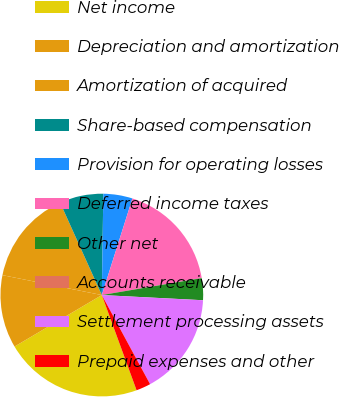<chart> <loc_0><loc_0><loc_500><loc_500><pie_chart><fcel>Net income<fcel>Depreciation and amortization<fcel>Amortization of acquired<fcel>Share-based compensation<fcel>Provision for operating losses<fcel>Deferred income taxes<fcel>Other net<fcel>Accounts receivable<fcel>Settlement processing assets<fcel>Prepaid expenses and other<nl><fcel>22.09%<fcel>11.63%<fcel>15.11%<fcel>6.98%<fcel>4.65%<fcel>17.44%<fcel>3.49%<fcel>0.01%<fcel>16.28%<fcel>2.33%<nl></chart> 